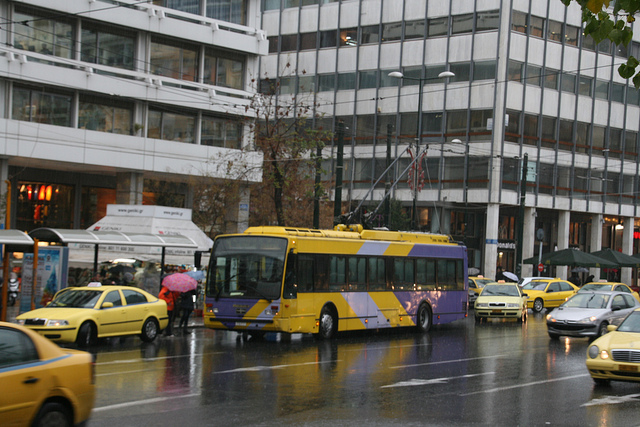<image>What country is it? It is ambiguous what country it is. It could be the United States, China, Germany, America, Spain or unknown. What country is it? I am not sure what country it is. It can be any of the following: United States, USA, China, Germany, America, or Spain. 